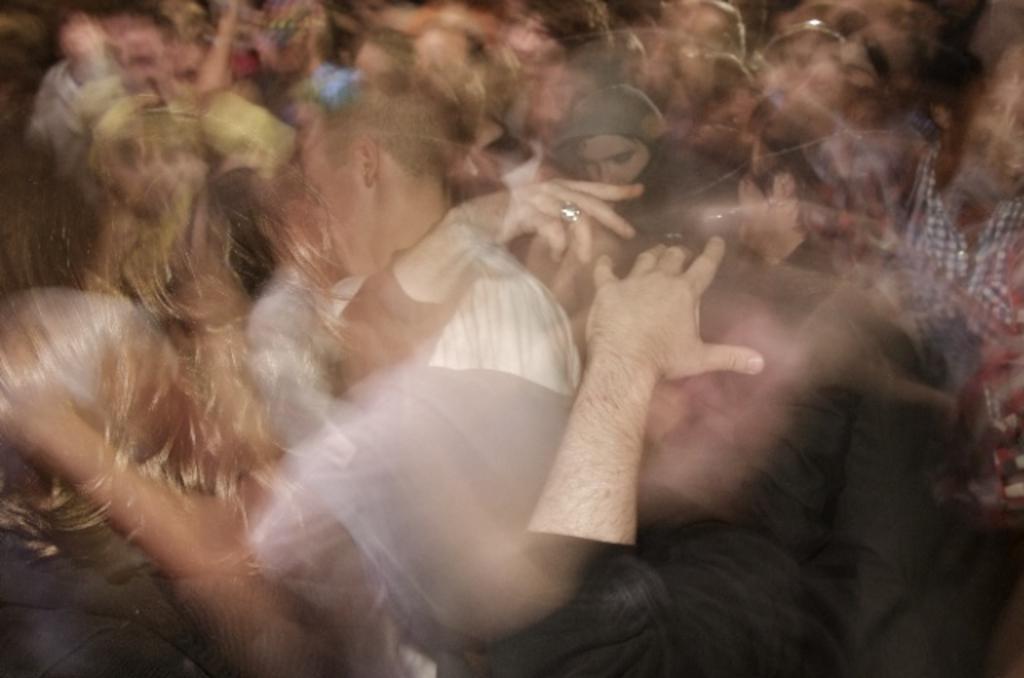In one or two sentences, can you explain what this image depicts? This image is a little blurred. This image is an edited image. In this image there are few people. 